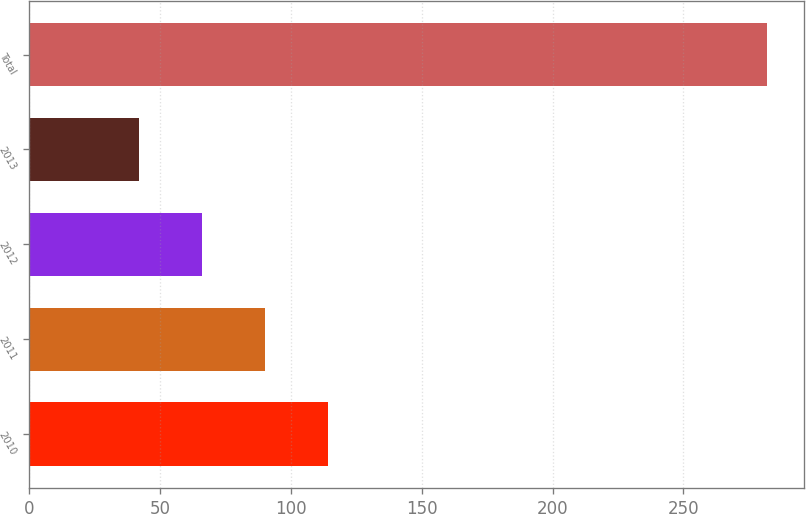Convert chart. <chart><loc_0><loc_0><loc_500><loc_500><bar_chart><fcel>2010<fcel>2011<fcel>2012<fcel>2013<fcel>Total<nl><fcel>114<fcel>90<fcel>66<fcel>42<fcel>282<nl></chart> 